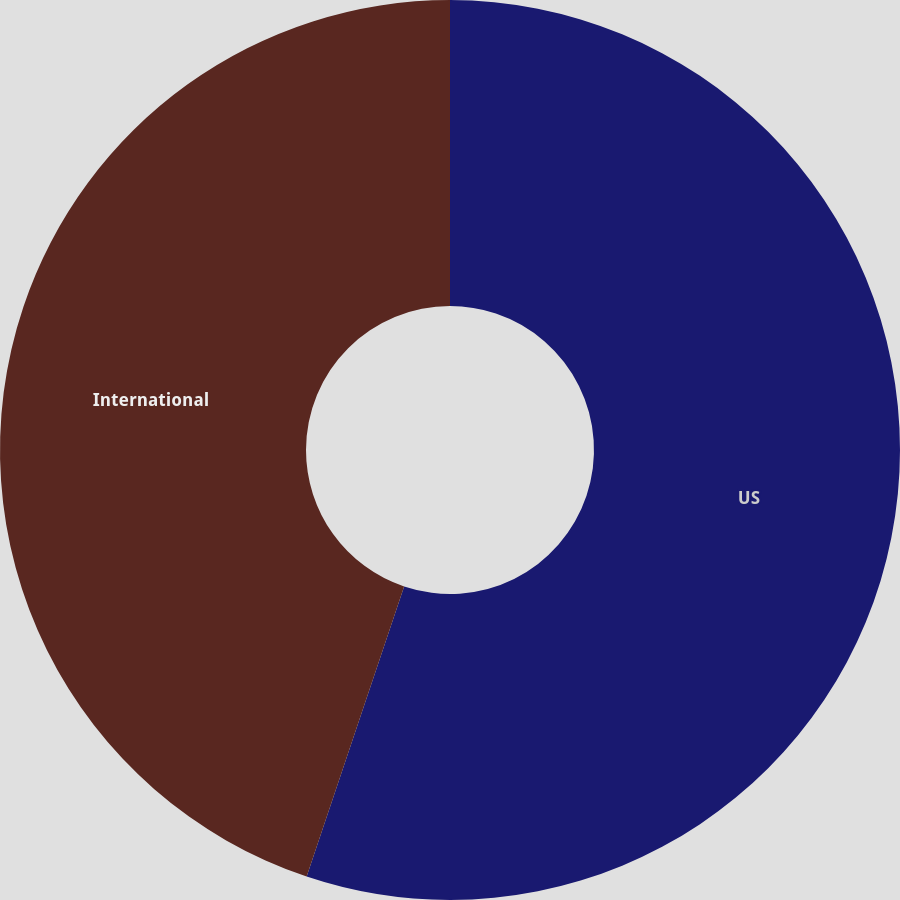<chart> <loc_0><loc_0><loc_500><loc_500><pie_chart><fcel>US<fcel>International<nl><fcel>55.16%<fcel>44.84%<nl></chart> 